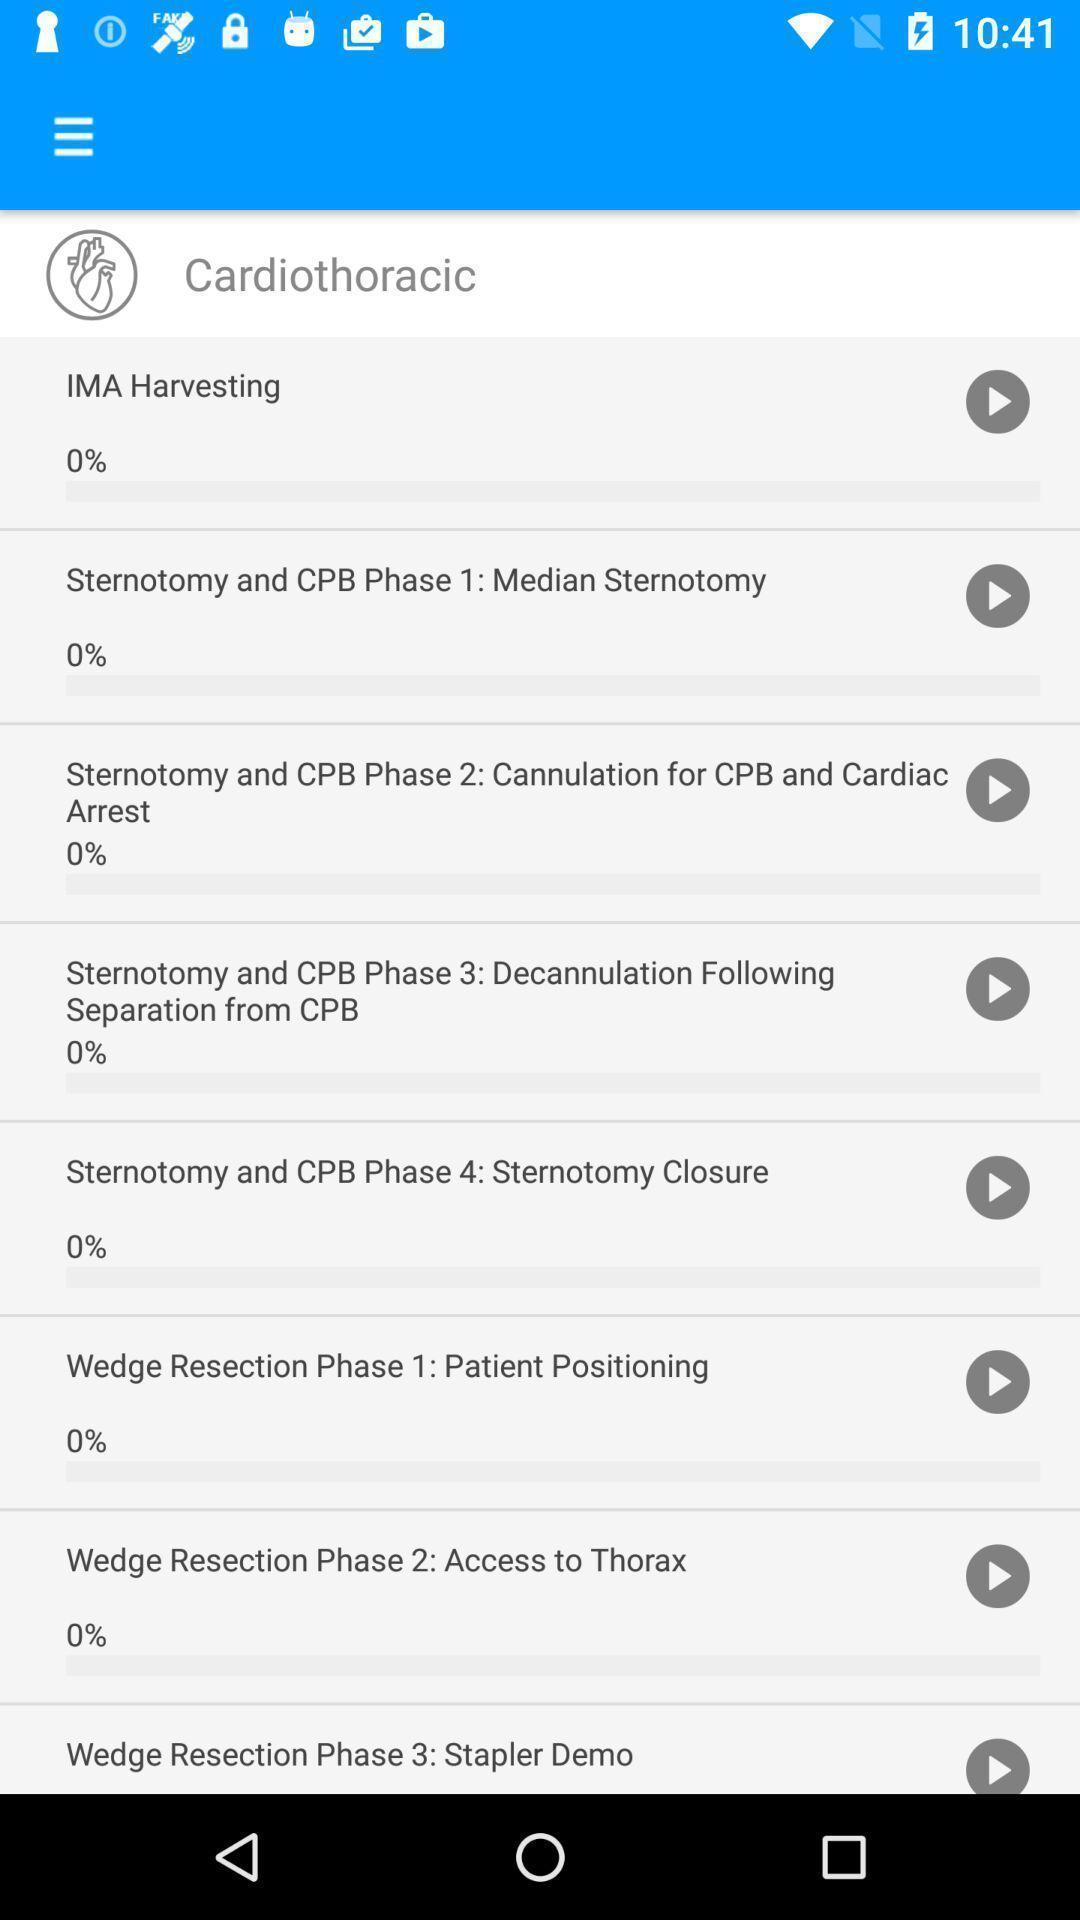Provide a textual representation of this image. Screen displaying the page of a medical app. 